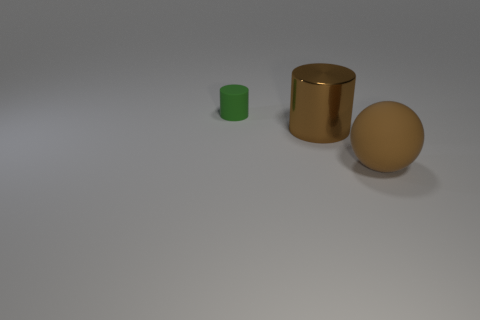Add 1 tiny blue matte cylinders. How many objects exist? 4 Subtract all cylinders. How many objects are left? 1 Add 3 shiny cylinders. How many shiny cylinders exist? 4 Subtract 0 blue cubes. How many objects are left? 3 Subtract all brown cylinders. Subtract all red cubes. How many cylinders are left? 1 Subtract all small green matte cylinders. Subtract all tiny purple matte spheres. How many objects are left? 2 Add 2 big metal cylinders. How many big metal cylinders are left? 3 